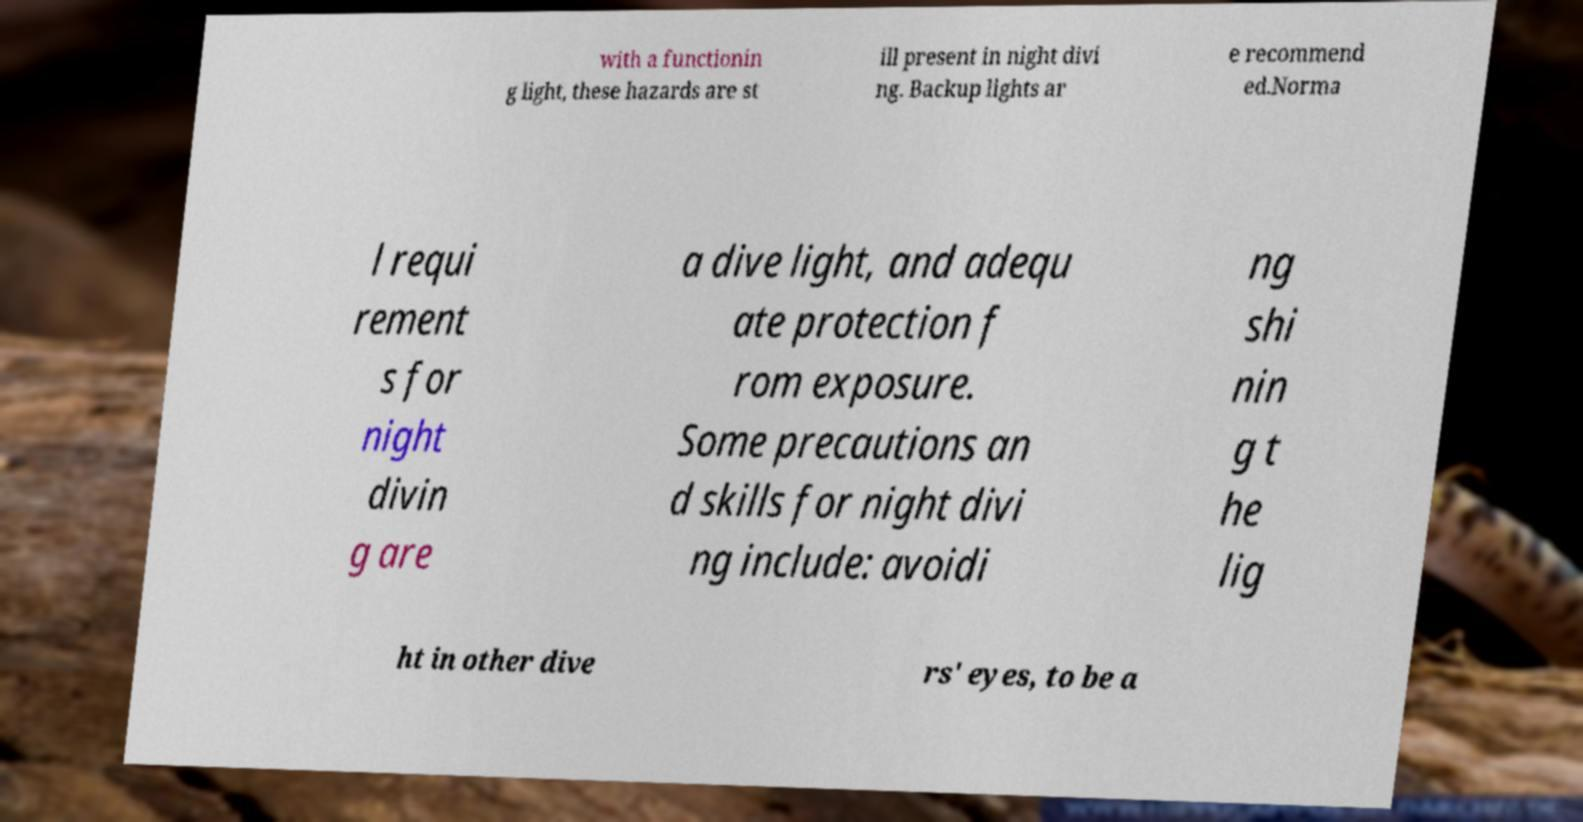Could you extract and type out the text from this image? with a functionin g light, these hazards are st ill present in night divi ng. Backup lights ar e recommend ed.Norma l requi rement s for night divin g are a dive light, and adequ ate protection f rom exposure. Some precautions an d skills for night divi ng include: avoidi ng shi nin g t he lig ht in other dive rs' eyes, to be a 